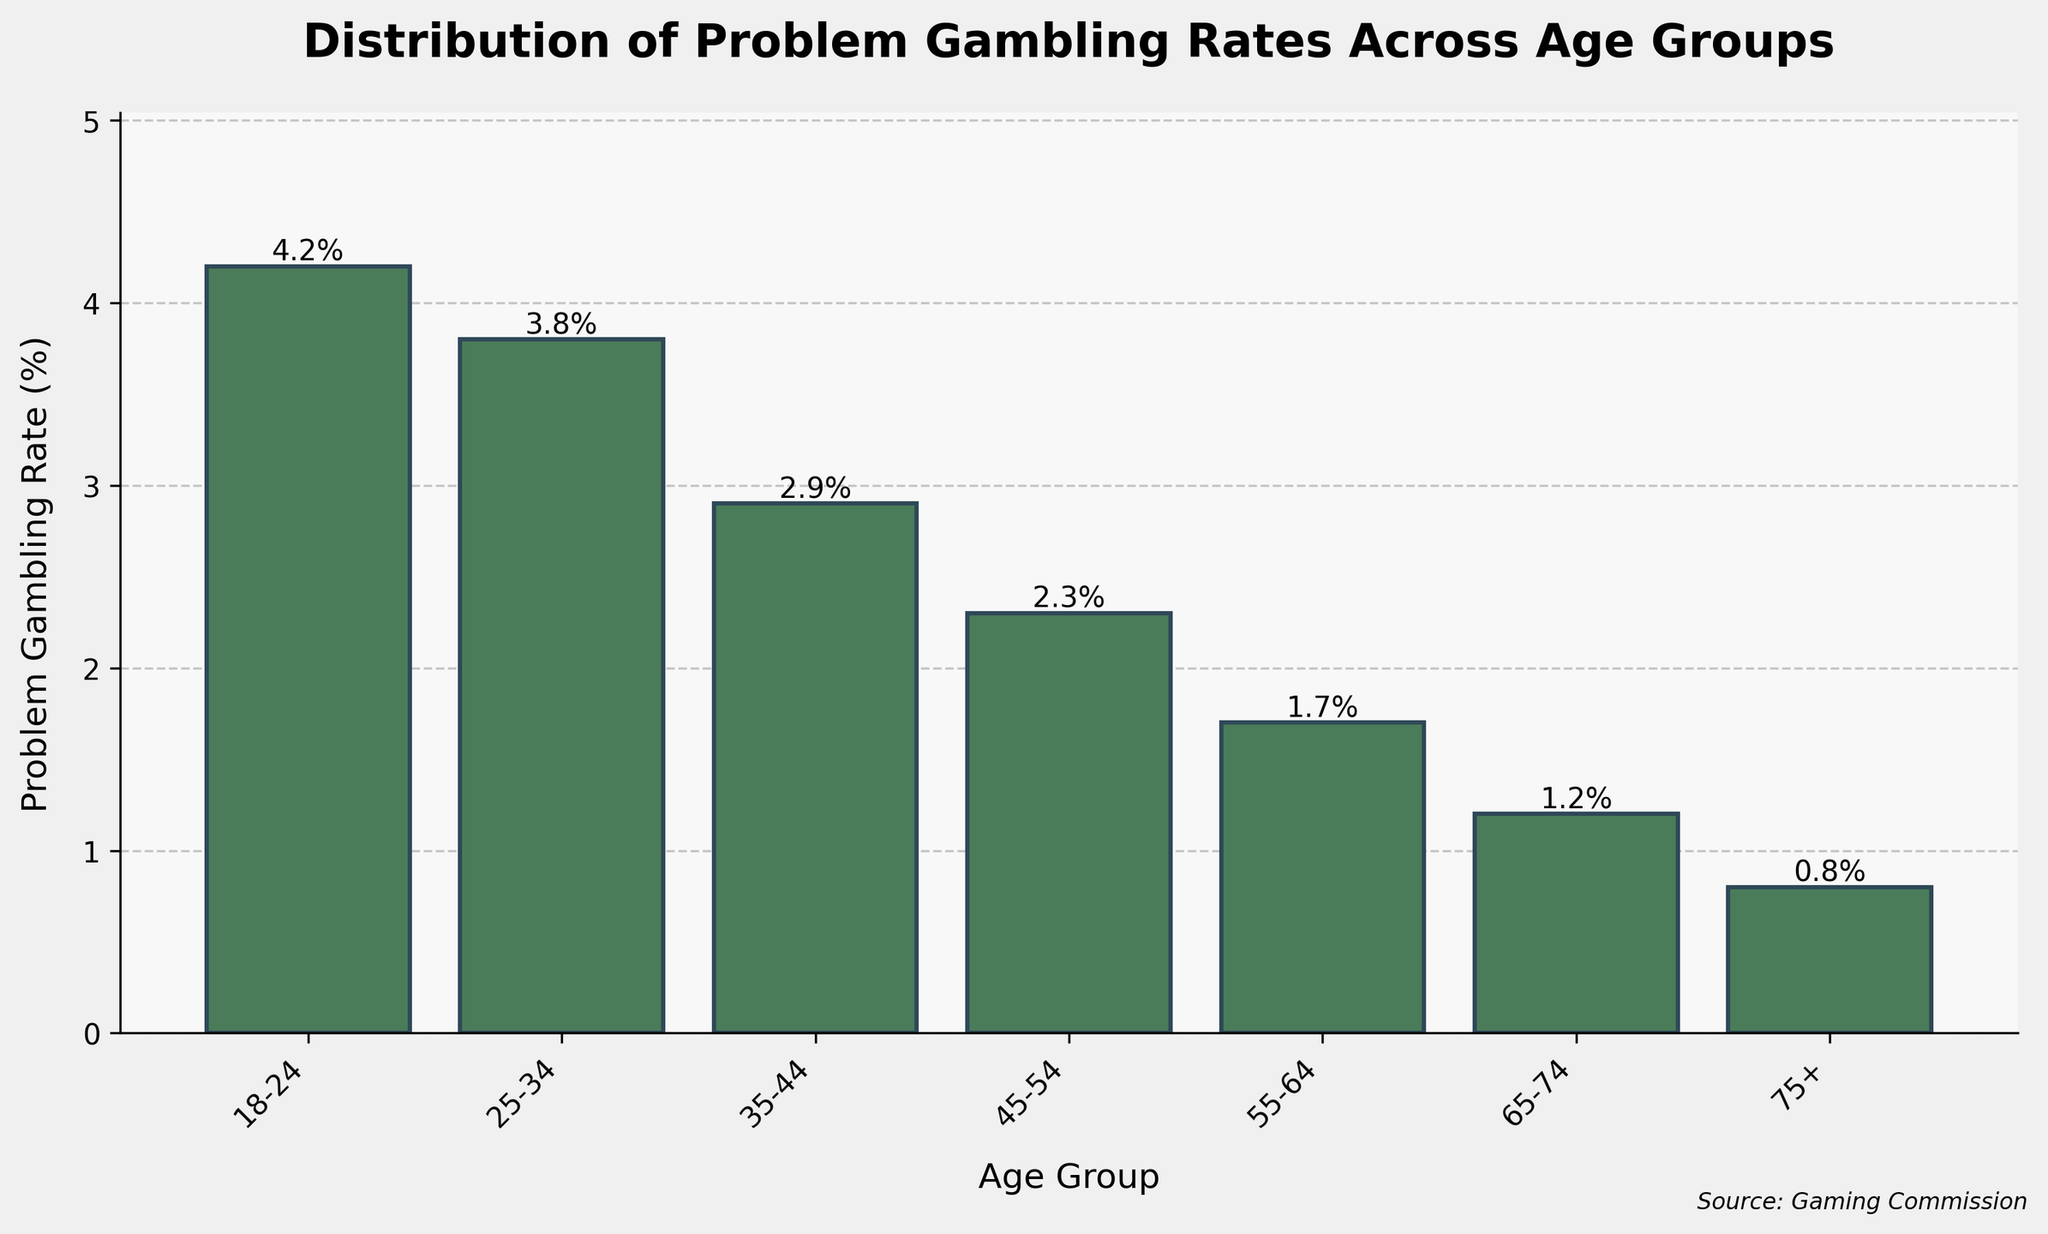What is the problem gambling rate for the 25-34 age group? The chart shows the problem gambling rate for each age group. For the 25-34 age group, the bar is labeled with a problem gambling rate of 3.8%.
Answer: 3.8% Which age group has the highest problem gambling rate? To find the age group with the highest problem gambling rate, compare the heights of the bars. The 18-24 age group's bar is the tallest, indicating the highest rate at 4.2%.
Answer: 18-24 How does the problem gambling rate for the 35-44 age group compare to the 45-54 age group? By comparing the heights of the bars for these two age groups, the 35-44 age group has a higher problem gambling rate (2.9%) than the 45-54 age group (2.3%).
Answer: Higher Which age group has the lowest problem gambling rate? The bar for the 75+ age group is the shortest among all the bars, indicating the lowest problem gambling rate at 0.8%.
Answer: 75+ What is the difference in problem gambling rates between the 18-24 and 65-74 age groups? The problem gambling rate for the 18-24 age group is 4.2%, while for the 65-74 age group, it is 1.2%. The difference is calculated as 4.2% - 1.2% = 3%.
Answer: 3% What trend can be observed in the problem gambling rates as age increases? By observing the heights of the bars from left to right, there is a decreasing trend in problem gambling rates as age increases. The rates steadily drop from 4.2% in the 18-24 age group to 0.8% in the 75+ age group.
Answer: Decreasing Comparing the 25-34 and 55-64 age groups, how many percentage points higher is the problem gambling rate for the younger group? The problem gambling rate for the 25-34 age group is 3.8%, whereas for the 55-64 age group, it is 1.7%. The difference in percentage points is 3.8% - 1.7% = 2.1%.
Answer: 2.1% What is the average problem gambling rate across all age groups? Sum the problem gambling rates for all age groups (4.2 + 3.8 + 2.9 + 2.3 + 1.7 + 1.2 + 0.8 = 16.9) and divide by the number of age groups (7). The average rate is 16.9 / 7 ≈ 2.41%.
Answer: 2.41% What is the visual trend observed in the height of the bars from left to right? The heights of the bars in the bar chart decrease steadily from left to right, indicating a declining trend in problem gambling rates as age increases.
Answer: Decreasing How does the problem gambling rate for the 55-64 age group compare to the average problem gambling rate across all age groups? The average problem gambling rate across all age groups is approximately 2.41%. The rate for the 55-64 age group is 1.7%, which is lower than the average rate.
Answer: Lower 